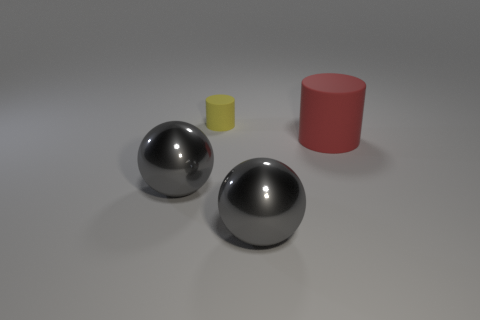What is the big thing behind the gray ball to the left of the large gray metallic ball to the right of the yellow matte object made of?
Keep it short and to the point. Rubber. Do the rubber thing left of the large red rubber object and the large cylinder have the same color?
Offer a very short reply. No. What material is the big thing that is in front of the large cylinder and right of the yellow object?
Ensure brevity in your answer.  Metal. Are there any things that have the same size as the yellow cylinder?
Provide a short and direct response. No. What number of large things are there?
Your answer should be very brief. 3. There is a yellow cylinder; what number of rubber objects are on the right side of it?
Give a very brief answer. 1. Is the yellow object made of the same material as the large red object?
Offer a terse response. Yes. How many rubber objects are both in front of the yellow thing and behind the big matte thing?
Offer a very short reply. 0. How many other objects are there of the same color as the large cylinder?
Your answer should be compact. 0. What number of brown objects are large spheres or objects?
Give a very brief answer. 0. 